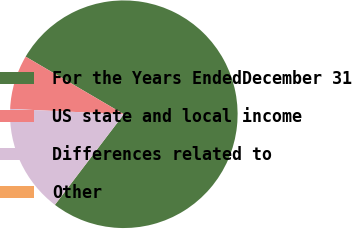Convert chart. <chart><loc_0><loc_0><loc_500><loc_500><pie_chart><fcel>For the Years EndedDecember 31<fcel>US state and local income<fcel>Differences related to<fcel>Other<nl><fcel>76.91%<fcel>7.7%<fcel>15.39%<fcel>0.01%<nl></chart> 